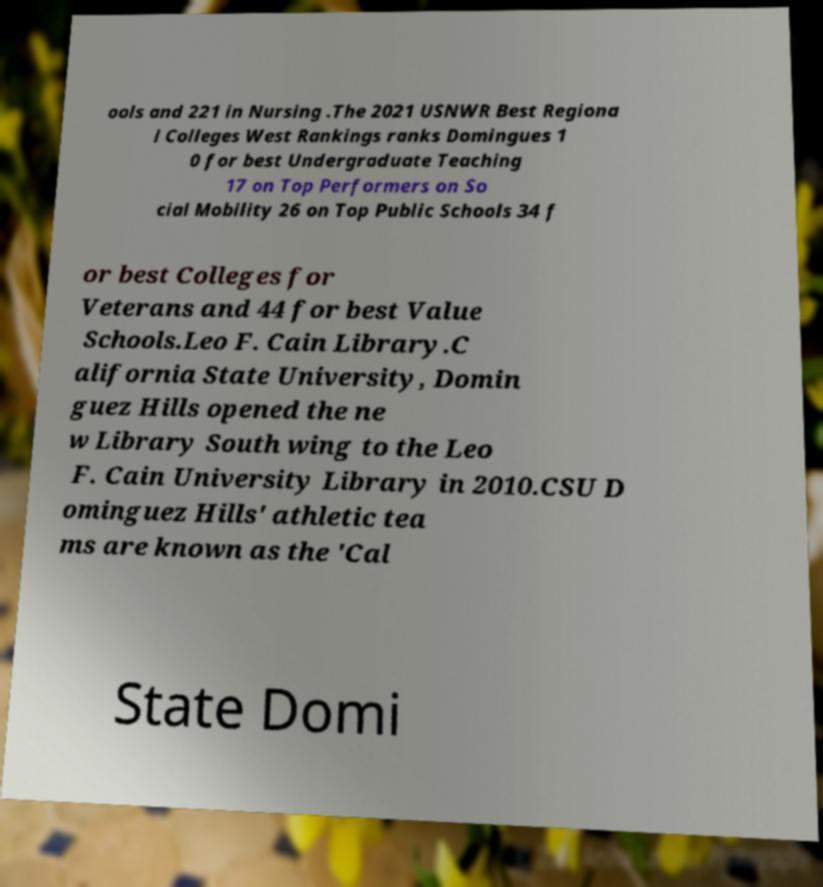For documentation purposes, I need the text within this image transcribed. Could you provide that? ools and 221 in Nursing .The 2021 USNWR Best Regiona l Colleges West Rankings ranks Domingues 1 0 for best Undergraduate Teaching 17 on Top Performers on So cial Mobility 26 on Top Public Schools 34 f or best Colleges for Veterans and 44 for best Value Schools.Leo F. Cain Library.C alifornia State University, Domin guez Hills opened the ne w Library South wing to the Leo F. Cain University Library in 2010.CSU D ominguez Hills' athletic tea ms are known as the 'Cal State Domi 